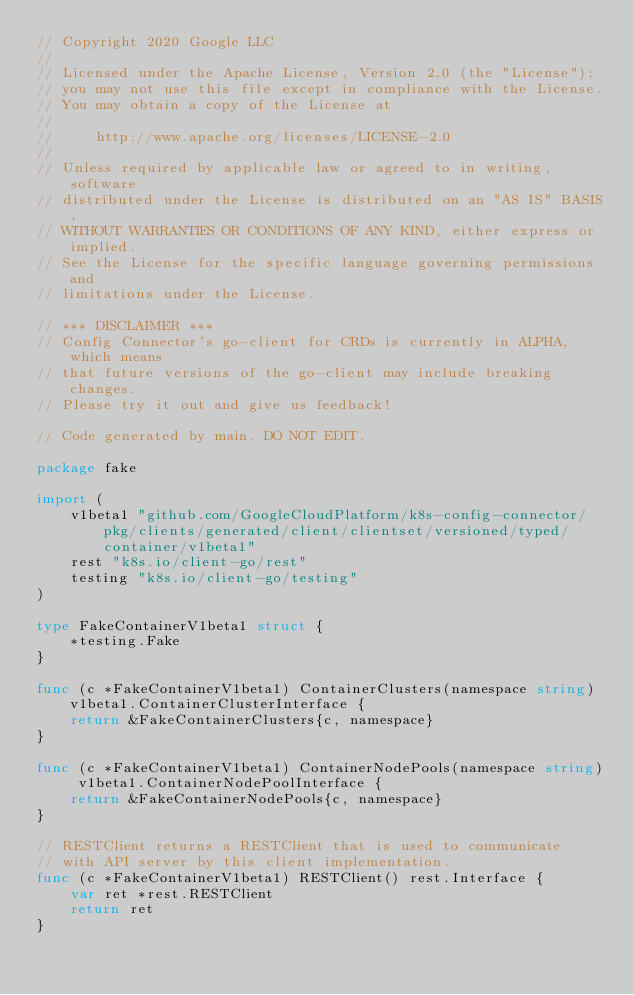<code> <loc_0><loc_0><loc_500><loc_500><_Go_>// Copyright 2020 Google LLC
//
// Licensed under the Apache License, Version 2.0 (the "License");
// you may not use this file except in compliance with the License.
// You may obtain a copy of the License at
//
//     http://www.apache.org/licenses/LICENSE-2.0
//
// Unless required by applicable law or agreed to in writing, software
// distributed under the License is distributed on an "AS IS" BASIS,
// WITHOUT WARRANTIES OR CONDITIONS OF ANY KIND, either express or implied.
// See the License for the specific language governing permissions and
// limitations under the License.

// *** DISCLAIMER ***
// Config Connector's go-client for CRDs is currently in ALPHA, which means
// that future versions of the go-client may include breaking changes.
// Please try it out and give us feedback!

// Code generated by main. DO NOT EDIT.

package fake

import (
	v1beta1 "github.com/GoogleCloudPlatform/k8s-config-connector/pkg/clients/generated/client/clientset/versioned/typed/container/v1beta1"
	rest "k8s.io/client-go/rest"
	testing "k8s.io/client-go/testing"
)

type FakeContainerV1beta1 struct {
	*testing.Fake
}

func (c *FakeContainerV1beta1) ContainerClusters(namespace string) v1beta1.ContainerClusterInterface {
	return &FakeContainerClusters{c, namespace}
}

func (c *FakeContainerV1beta1) ContainerNodePools(namespace string) v1beta1.ContainerNodePoolInterface {
	return &FakeContainerNodePools{c, namespace}
}

// RESTClient returns a RESTClient that is used to communicate
// with API server by this client implementation.
func (c *FakeContainerV1beta1) RESTClient() rest.Interface {
	var ret *rest.RESTClient
	return ret
}
</code> 